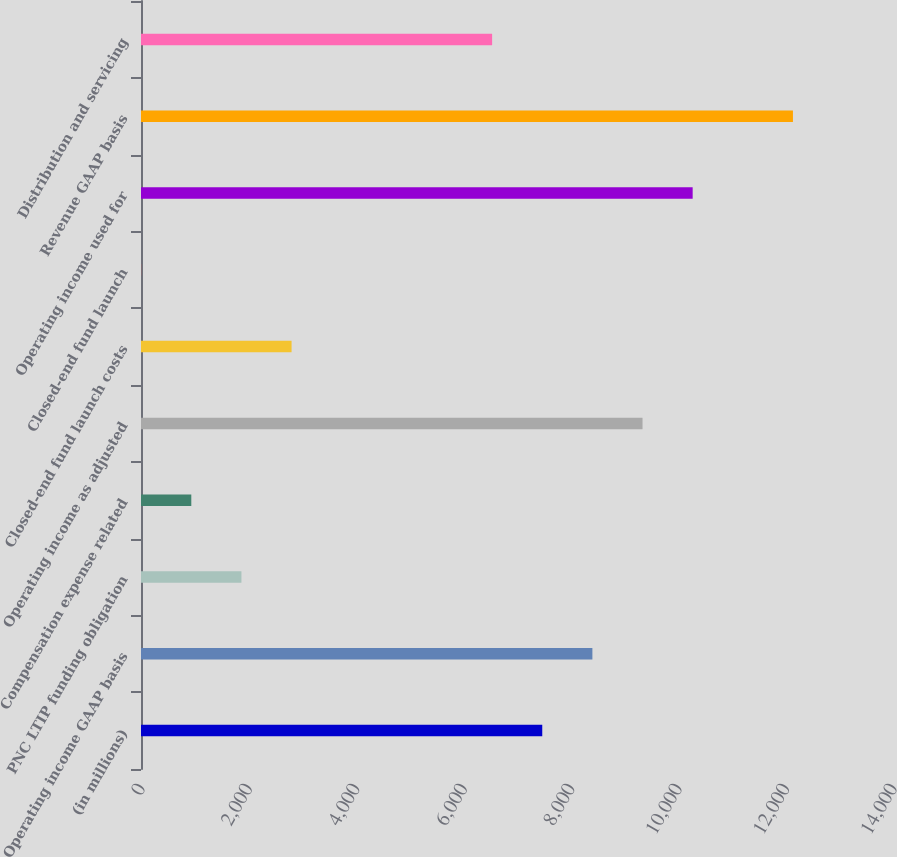<chart> <loc_0><loc_0><loc_500><loc_500><bar_chart><fcel>(in millions)<fcel>Operating income GAAP basis<fcel>PNC LTIP funding obligation<fcel>Compensation expense related<fcel>Operating income as adjusted<fcel>Closed-end fund launch costs<fcel>Closed-end fund launch<fcel>Operating income used for<fcel>Revenue GAAP basis<fcel>Distribution and servicing<nl><fcel>7470.2<fcel>8403.6<fcel>1869.8<fcel>936.4<fcel>9337<fcel>2803.2<fcel>3<fcel>10270.4<fcel>12137.2<fcel>6536.8<nl></chart> 